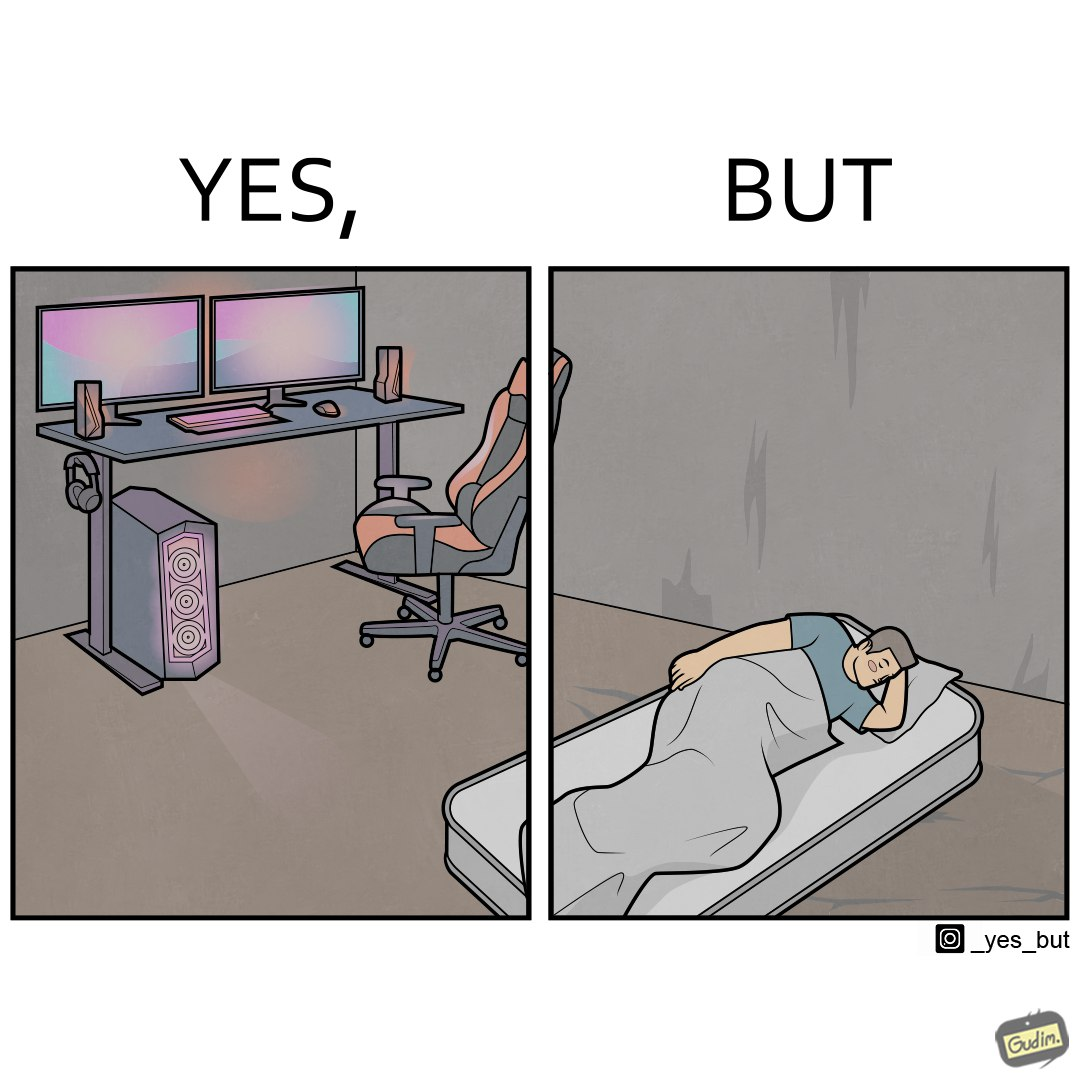What is the satirical meaning behind this image? The image is funny because the person has a lot of furniture for his computer but none for himself. 